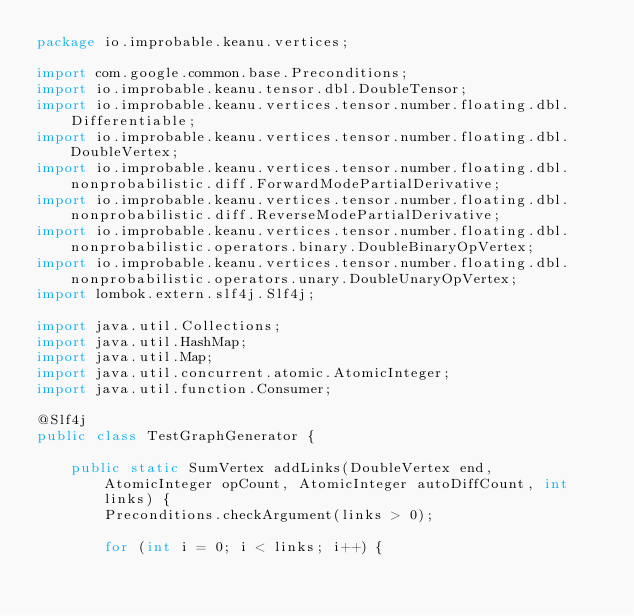<code> <loc_0><loc_0><loc_500><loc_500><_Java_>package io.improbable.keanu.vertices;

import com.google.common.base.Preconditions;
import io.improbable.keanu.tensor.dbl.DoubleTensor;
import io.improbable.keanu.vertices.tensor.number.floating.dbl.Differentiable;
import io.improbable.keanu.vertices.tensor.number.floating.dbl.DoubleVertex;
import io.improbable.keanu.vertices.tensor.number.floating.dbl.nonprobabilistic.diff.ForwardModePartialDerivative;
import io.improbable.keanu.vertices.tensor.number.floating.dbl.nonprobabilistic.diff.ReverseModePartialDerivative;
import io.improbable.keanu.vertices.tensor.number.floating.dbl.nonprobabilistic.operators.binary.DoubleBinaryOpVertex;
import io.improbable.keanu.vertices.tensor.number.floating.dbl.nonprobabilistic.operators.unary.DoubleUnaryOpVertex;
import lombok.extern.slf4j.Slf4j;

import java.util.Collections;
import java.util.HashMap;
import java.util.Map;
import java.util.concurrent.atomic.AtomicInteger;
import java.util.function.Consumer;

@Slf4j
public class TestGraphGenerator {

    public static SumVertex addLinks(DoubleVertex end, AtomicInteger opCount, AtomicInteger autoDiffCount, int links) {
        Preconditions.checkArgument(links > 0);

        for (int i = 0; i < links; i++) {</code> 